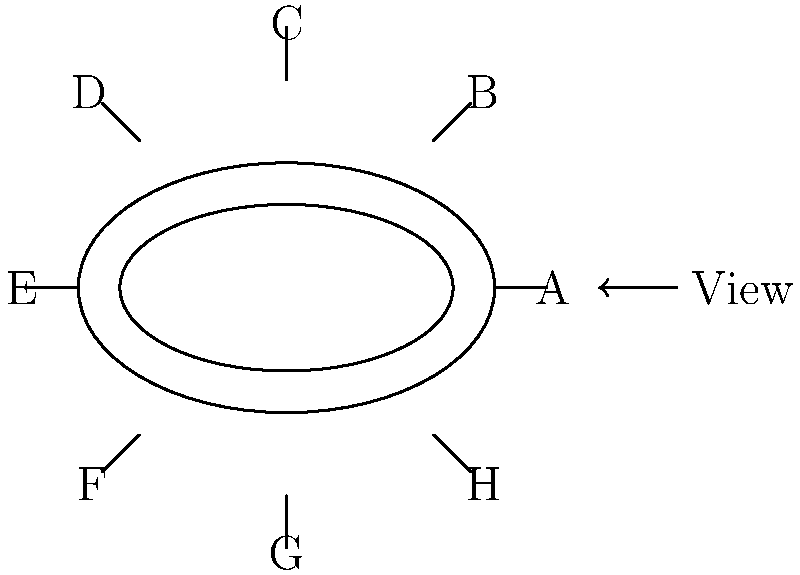As a football coach focusing on character development, you're planning a team-building exercise where players will rotate through different stadium sections to gain various perspectives. Based on the stadium layout shown, which section would offer the correct perspective view if you were standing at the point indicated by the "View" arrow? To determine the correct perspective view, let's analyze the stadium layout step-by-step:

1. The "View" arrow points towards the stadium from the right side of the diagram.

2. The stadium is divided into 8 sections, labeled A through H.

3. The sections are arranged in a clockwise manner, starting with A on the right side.

4. The viewing direction aligns directly with section A.

5. From this perspective:
   - Section A would be directly in front of the viewer.
   - Sections H and B would be to the left and right of A, respectively.
   - Sections G and C would be further to the sides.
   - Sections F, E, and D would be on the far side of the stadium.

6. This perspective offers a clear view of the field and the opposite side of the stadium.

7. As a character-building exercise, this view allows players to see:
   - The full expanse of the field, emphasizing the importance of teamwork across the entire playing area.
   - The opposing side's seating, reminding them to consider different perspectives and respect for opponents.
   - The curved nature of the stadium, symbolizing how all sections and fans come together to support the team.

Therefore, the section that offers the correct perspective view from the indicated viewing point is A.
Answer: A 